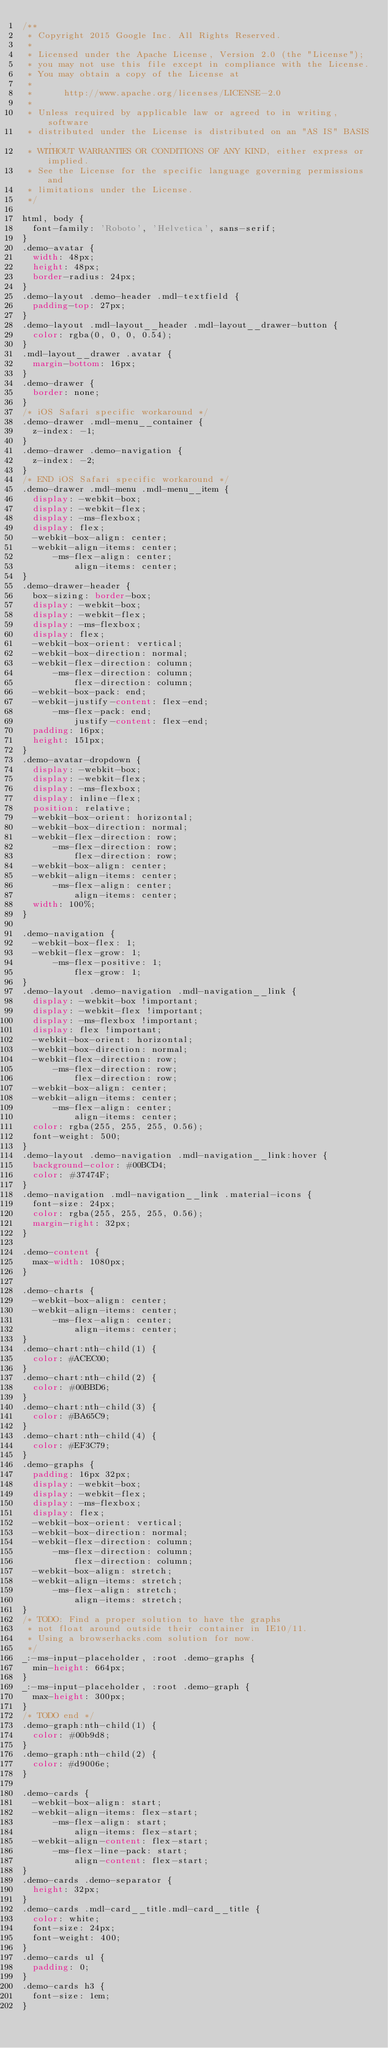Convert code to text. <code><loc_0><loc_0><loc_500><loc_500><_CSS_>/**
 * Copyright 2015 Google Inc. All Rights Reserved.
 *
 * Licensed under the Apache License, Version 2.0 (the "License");
 * you may not use this file except in compliance with the License.
 * You may obtain a copy of the License at
 *
 *      http://www.apache.org/licenses/LICENSE-2.0
 *
 * Unless required by applicable law or agreed to in writing, software
 * distributed under the License is distributed on an "AS IS" BASIS,
 * WITHOUT WARRANTIES OR CONDITIONS OF ANY KIND, either express or implied.
 * See the License for the specific language governing permissions and
 * limitations under the License.
 */

html, body {
  font-family: 'Roboto', 'Helvetica', sans-serif;
}
.demo-avatar {
  width: 48px;
  height: 48px;
  border-radius: 24px;
}
.demo-layout .demo-header .mdl-textfield {
  padding-top: 27px;
}
.demo-layout .mdl-layout__header .mdl-layout__drawer-button {
  color: rgba(0, 0, 0, 0.54);
}
.mdl-layout__drawer .avatar {
  margin-bottom: 16px;
}
.demo-drawer {
  border: none;
}
/* iOS Safari specific workaround */
.demo-drawer .mdl-menu__container {
  z-index: -1;
}
.demo-drawer .demo-navigation {
  z-index: -2;
}
/* END iOS Safari specific workaround */
.demo-drawer .mdl-menu .mdl-menu__item {
  display: -webkit-box;
  display: -webkit-flex;
  display: -ms-flexbox;
  display: flex;
  -webkit-box-align: center;
  -webkit-align-items: center;
      -ms-flex-align: center;
          align-items: center;
}
.demo-drawer-header {
  box-sizing: border-box;
  display: -webkit-box;
  display: -webkit-flex;
  display: -ms-flexbox;
  display: flex;
  -webkit-box-orient: vertical;
  -webkit-box-direction: normal;
  -webkit-flex-direction: column;
      -ms-flex-direction: column;
          flex-direction: column;
  -webkit-box-pack: end;
  -webkit-justify-content: flex-end;
      -ms-flex-pack: end;
          justify-content: flex-end;
  padding: 16px;
  height: 151px;
}
.demo-avatar-dropdown {
  display: -webkit-box;
  display: -webkit-flex;
  display: -ms-flexbox;
  display: inline-flex;
  position: relative;
  -webkit-box-orient: horizontal;
  -webkit-box-direction: normal;
  -webkit-flex-direction: row;
      -ms-flex-direction: row;
          flex-direction: row;
  -webkit-box-align: center;
  -webkit-align-items: center;
      -ms-flex-align: center;
          align-items: center;
  width: 100%;
}

.demo-navigation {
  -webkit-box-flex: 1;
  -webkit-flex-grow: 1;
      -ms-flex-positive: 1;
          flex-grow: 1;
}
.demo-layout .demo-navigation .mdl-navigation__link {
  display: -webkit-box !important;
  display: -webkit-flex !important;
  display: -ms-flexbox !important;
  display: flex !important;
  -webkit-box-orient: horizontal;
  -webkit-box-direction: normal;
  -webkit-flex-direction: row;
      -ms-flex-direction: row;
          flex-direction: row;
  -webkit-box-align: center;
  -webkit-align-items: center;
      -ms-flex-align: center;
          align-items: center;
  color: rgba(255, 255, 255, 0.56);
  font-weight: 500;
}
.demo-layout .demo-navigation .mdl-navigation__link:hover {
  background-color: #00BCD4;
  color: #37474F;
}
.demo-navigation .mdl-navigation__link .material-icons {
  font-size: 24px;
  color: rgba(255, 255, 255, 0.56);
  margin-right: 32px;
}

.demo-content {
  max-width: 1080px;
}

.demo-charts {
  -webkit-box-align: center;
  -webkit-align-items: center;
      -ms-flex-align: center;
          align-items: center;
}
.demo-chart:nth-child(1) {
  color: #ACEC00;
}
.demo-chart:nth-child(2) {
  color: #00BBD6;
}
.demo-chart:nth-child(3) {
  color: #BA65C9;
}
.demo-chart:nth-child(4) {
  color: #EF3C79;
}
.demo-graphs {
  padding: 16px 32px;
  display: -webkit-box;
  display: -webkit-flex;
  display: -ms-flexbox;
  display: flex;
  -webkit-box-orient: vertical;
  -webkit-box-direction: normal;
  -webkit-flex-direction: column;
      -ms-flex-direction: column;
          flex-direction: column;
  -webkit-box-align: stretch;
  -webkit-align-items: stretch;
      -ms-flex-align: stretch;
          align-items: stretch;
}
/* TODO: Find a proper solution to have the graphs
 * not float around outside their container in IE10/11.
 * Using a browserhacks.com solution for now.
 */
_:-ms-input-placeholder, :root .demo-graphs {
  min-height: 664px;
}
_:-ms-input-placeholder, :root .demo-graph {
  max-height: 300px;
}
/* TODO end */
.demo-graph:nth-child(1) {
  color: #00b9d8;
}
.demo-graph:nth-child(2) {
  color: #d9006e;
}

.demo-cards {
  -webkit-box-align: start;
  -webkit-align-items: flex-start;
      -ms-flex-align: start;
          align-items: flex-start;
  -webkit-align-content: flex-start;
      -ms-flex-line-pack: start;
          align-content: flex-start;
}
.demo-cards .demo-separator {
  height: 32px;
}
.demo-cards .mdl-card__title.mdl-card__title {
  color: white;
  font-size: 24px;
  font-weight: 400;
}
.demo-cards ul {
  padding: 0;
}
.demo-cards h3 {
  font-size: 1em;
}</code> 